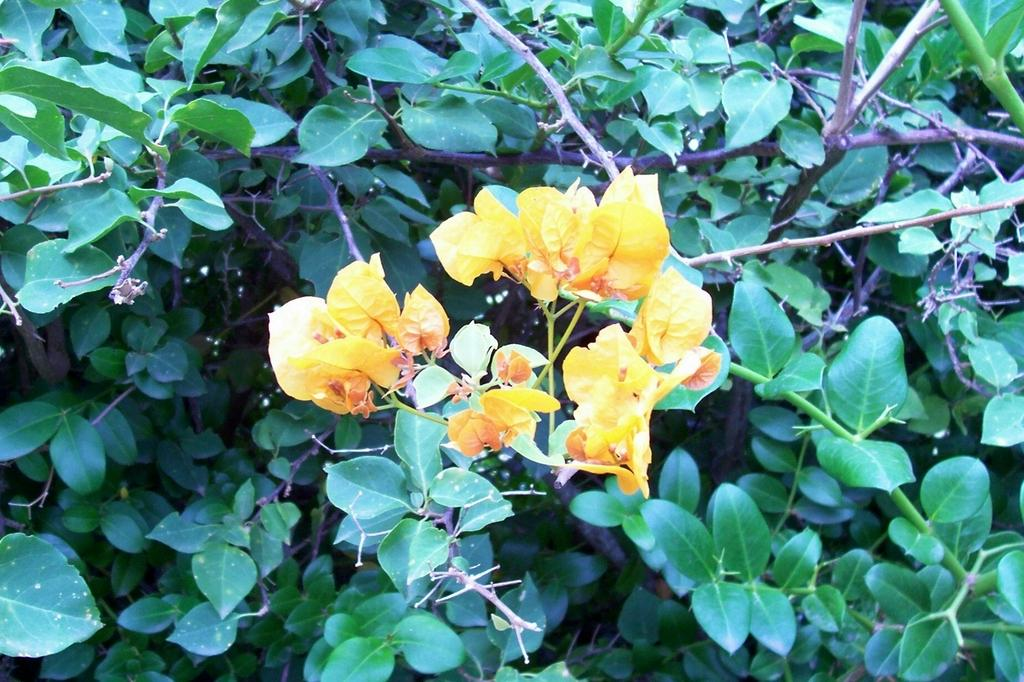What type of flowers can be seen in the image? There are small yellow flowers in the image. What color are the leaves surrounding the flowers? The leaves surrounding the flowers are green. Is there a stream of water flowing through the flowers in the image? No, there is no stream of water present in the image. 